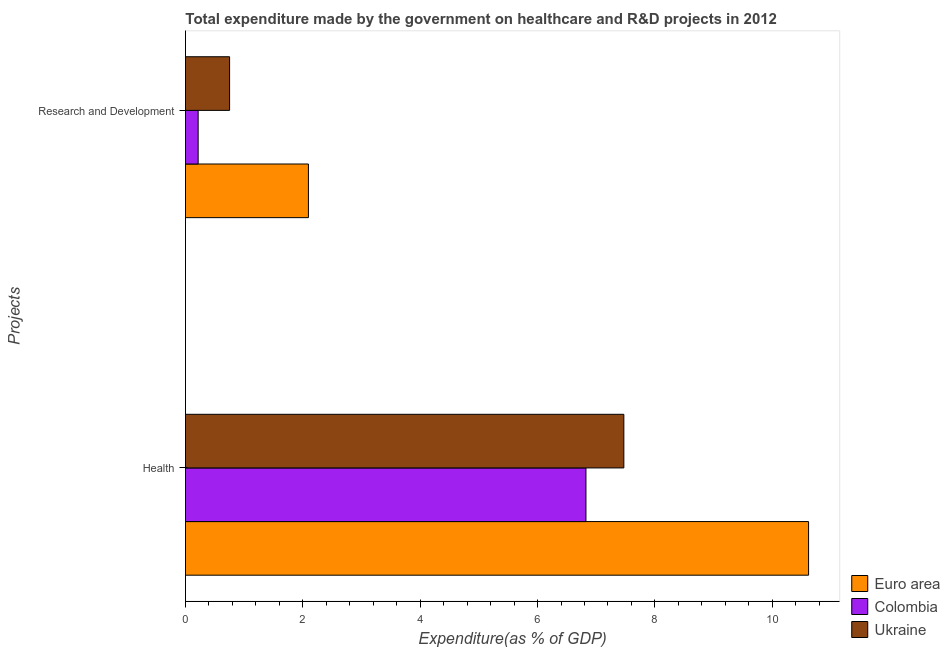Are the number of bars on each tick of the Y-axis equal?
Provide a short and direct response. Yes. What is the label of the 1st group of bars from the top?
Give a very brief answer. Research and Development. What is the expenditure in r&d in Colombia?
Provide a short and direct response. 0.22. Across all countries, what is the maximum expenditure in healthcare?
Offer a very short reply. 10.62. Across all countries, what is the minimum expenditure in r&d?
Offer a very short reply. 0.22. What is the total expenditure in healthcare in the graph?
Keep it short and to the point. 24.91. What is the difference between the expenditure in healthcare in Euro area and that in Ukraine?
Your answer should be compact. 3.15. What is the difference between the expenditure in healthcare in Euro area and the expenditure in r&d in Colombia?
Make the answer very short. 10.4. What is the average expenditure in healthcare per country?
Make the answer very short. 8.3. What is the difference between the expenditure in healthcare and expenditure in r&d in Euro area?
Offer a very short reply. 8.52. In how many countries, is the expenditure in r&d greater than 3.6 %?
Ensure brevity in your answer.  0. What is the ratio of the expenditure in healthcare in Colombia to that in Ukraine?
Your answer should be compact. 0.91. Is the expenditure in r&d in Euro area less than that in Ukraine?
Give a very brief answer. No. What does the 3rd bar from the bottom in Research and Development represents?
Your response must be concise. Ukraine. How many bars are there?
Your answer should be very brief. 6. What is the difference between two consecutive major ticks on the X-axis?
Your response must be concise. 2. Does the graph contain any zero values?
Make the answer very short. No. Does the graph contain grids?
Ensure brevity in your answer.  No. Where does the legend appear in the graph?
Provide a short and direct response. Bottom right. What is the title of the graph?
Make the answer very short. Total expenditure made by the government on healthcare and R&D projects in 2012. Does "Vietnam" appear as one of the legend labels in the graph?
Your answer should be compact. No. What is the label or title of the X-axis?
Your answer should be very brief. Expenditure(as % of GDP). What is the label or title of the Y-axis?
Offer a terse response. Projects. What is the Expenditure(as % of GDP) in Euro area in Health?
Offer a terse response. 10.62. What is the Expenditure(as % of GDP) in Colombia in Health?
Provide a short and direct response. 6.83. What is the Expenditure(as % of GDP) of Ukraine in Health?
Your answer should be compact. 7.47. What is the Expenditure(as % of GDP) of Euro area in Research and Development?
Offer a terse response. 2.1. What is the Expenditure(as % of GDP) in Colombia in Research and Development?
Your answer should be compact. 0.22. What is the Expenditure(as % of GDP) in Ukraine in Research and Development?
Offer a terse response. 0.75. Across all Projects, what is the maximum Expenditure(as % of GDP) of Euro area?
Your response must be concise. 10.62. Across all Projects, what is the maximum Expenditure(as % of GDP) in Colombia?
Keep it short and to the point. 6.83. Across all Projects, what is the maximum Expenditure(as % of GDP) in Ukraine?
Ensure brevity in your answer.  7.47. Across all Projects, what is the minimum Expenditure(as % of GDP) in Euro area?
Give a very brief answer. 2.1. Across all Projects, what is the minimum Expenditure(as % of GDP) in Colombia?
Offer a very short reply. 0.22. Across all Projects, what is the minimum Expenditure(as % of GDP) of Ukraine?
Provide a succinct answer. 0.75. What is the total Expenditure(as % of GDP) in Euro area in the graph?
Offer a very short reply. 12.71. What is the total Expenditure(as % of GDP) of Colombia in the graph?
Provide a succinct answer. 7.04. What is the total Expenditure(as % of GDP) of Ukraine in the graph?
Offer a terse response. 8.22. What is the difference between the Expenditure(as % of GDP) of Euro area in Health and that in Research and Development?
Keep it short and to the point. 8.52. What is the difference between the Expenditure(as % of GDP) in Colombia in Health and that in Research and Development?
Provide a short and direct response. 6.61. What is the difference between the Expenditure(as % of GDP) in Ukraine in Health and that in Research and Development?
Make the answer very short. 6.72. What is the difference between the Expenditure(as % of GDP) of Euro area in Health and the Expenditure(as % of GDP) of Colombia in Research and Development?
Give a very brief answer. 10.4. What is the difference between the Expenditure(as % of GDP) of Euro area in Health and the Expenditure(as % of GDP) of Ukraine in Research and Development?
Your answer should be compact. 9.87. What is the difference between the Expenditure(as % of GDP) in Colombia in Health and the Expenditure(as % of GDP) in Ukraine in Research and Development?
Provide a short and direct response. 6.07. What is the average Expenditure(as % of GDP) in Euro area per Projects?
Make the answer very short. 6.36. What is the average Expenditure(as % of GDP) of Colombia per Projects?
Your answer should be compact. 3.52. What is the average Expenditure(as % of GDP) of Ukraine per Projects?
Offer a very short reply. 4.11. What is the difference between the Expenditure(as % of GDP) of Euro area and Expenditure(as % of GDP) of Colombia in Health?
Provide a succinct answer. 3.79. What is the difference between the Expenditure(as % of GDP) in Euro area and Expenditure(as % of GDP) in Ukraine in Health?
Ensure brevity in your answer.  3.15. What is the difference between the Expenditure(as % of GDP) in Colombia and Expenditure(as % of GDP) in Ukraine in Health?
Your answer should be compact. -0.65. What is the difference between the Expenditure(as % of GDP) of Euro area and Expenditure(as % of GDP) of Colombia in Research and Development?
Provide a short and direct response. 1.88. What is the difference between the Expenditure(as % of GDP) in Euro area and Expenditure(as % of GDP) in Ukraine in Research and Development?
Ensure brevity in your answer.  1.34. What is the difference between the Expenditure(as % of GDP) of Colombia and Expenditure(as % of GDP) of Ukraine in Research and Development?
Ensure brevity in your answer.  -0.54. What is the ratio of the Expenditure(as % of GDP) of Euro area in Health to that in Research and Development?
Keep it short and to the point. 5.07. What is the ratio of the Expenditure(as % of GDP) of Colombia in Health to that in Research and Development?
Ensure brevity in your answer.  31.64. What is the ratio of the Expenditure(as % of GDP) in Ukraine in Health to that in Research and Development?
Your answer should be compact. 9.94. What is the difference between the highest and the second highest Expenditure(as % of GDP) in Euro area?
Make the answer very short. 8.52. What is the difference between the highest and the second highest Expenditure(as % of GDP) in Colombia?
Provide a short and direct response. 6.61. What is the difference between the highest and the second highest Expenditure(as % of GDP) in Ukraine?
Provide a short and direct response. 6.72. What is the difference between the highest and the lowest Expenditure(as % of GDP) in Euro area?
Ensure brevity in your answer.  8.52. What is the difference between the highest and the lowest Expenditure(as % of GDP) of Colombia?
Provide a short and direct response. 6.61. What is the difference between the highest and the lowest Expenditure(as % of GDP) in Ukraine?
Your answer should be compact. 6.72. 